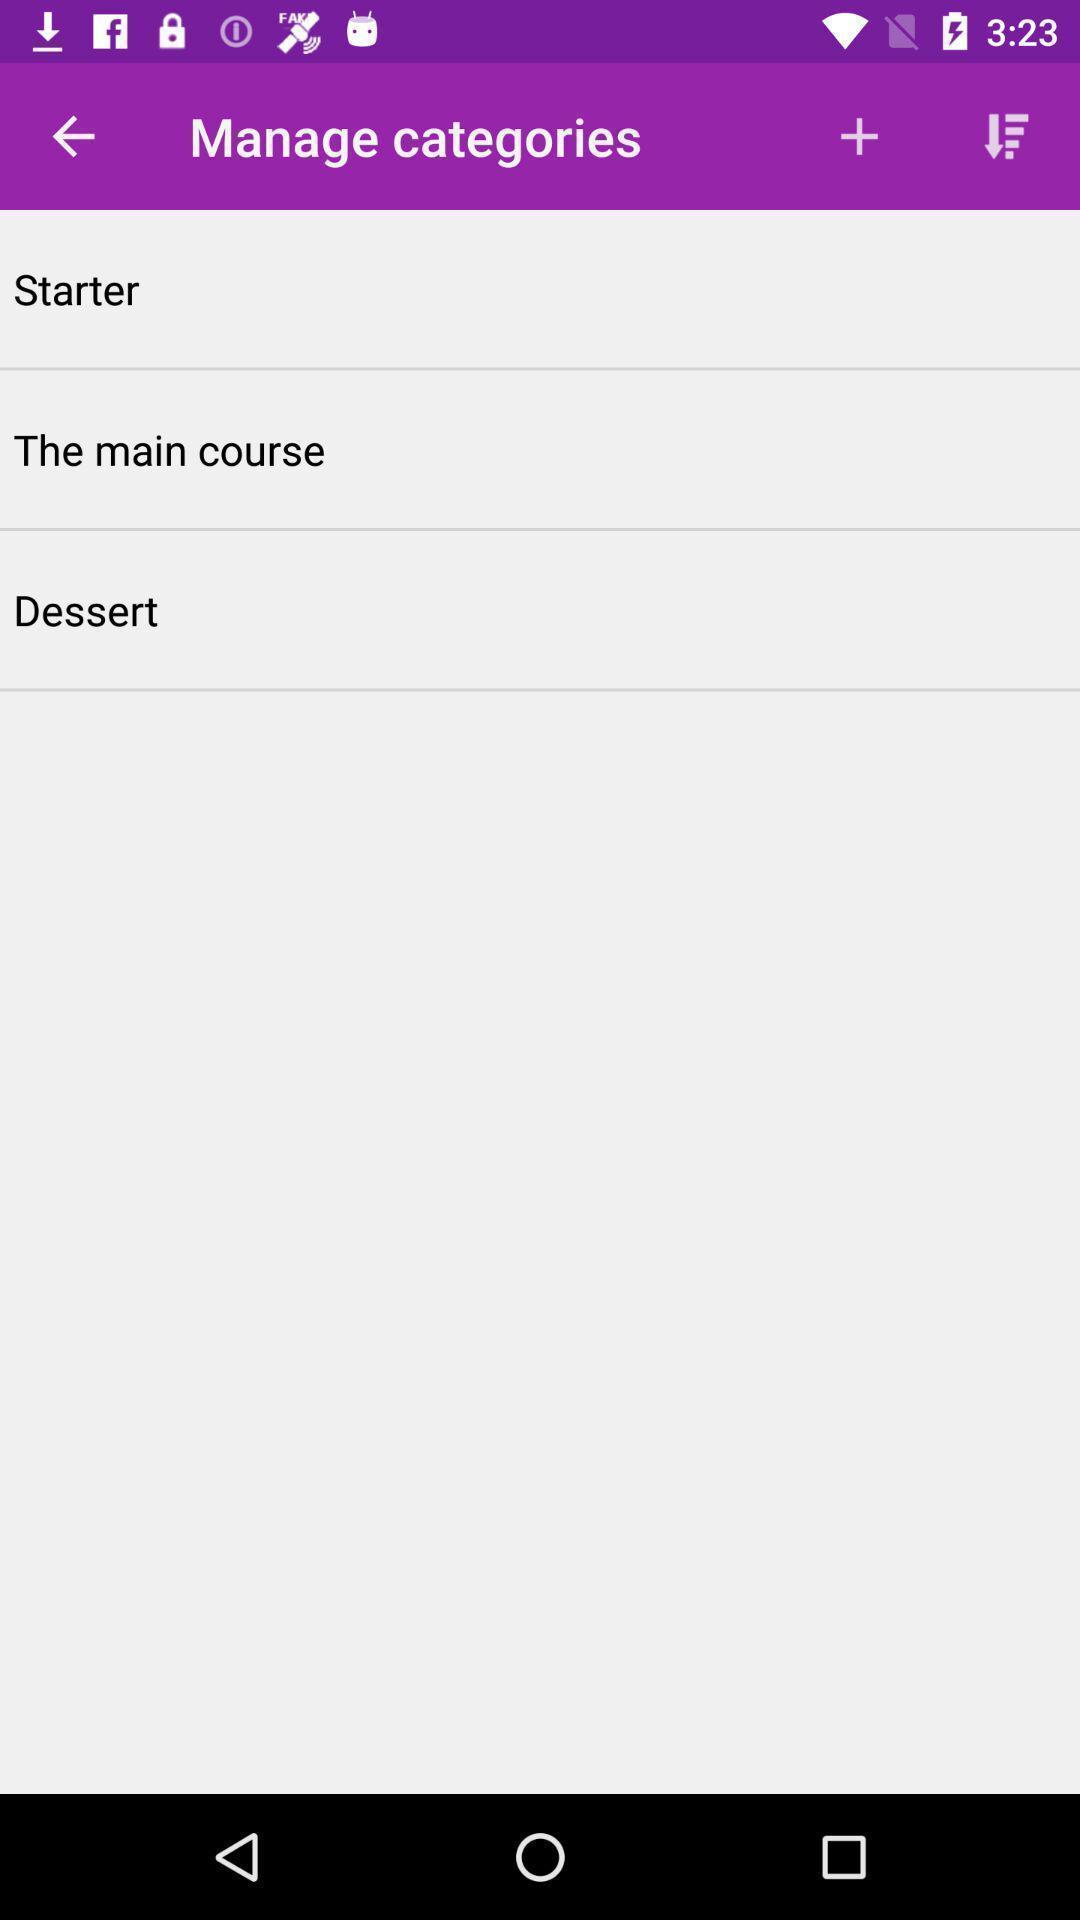Provide a textual representation of this image. Screen shows different options for food app. 